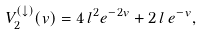<formula> <loc_0><loc_0><loc_500><loc_500>V ^ { ( \downarrow ) } _ { 2 } ( v ) = 4 \, l ^ { 2 } e ^ { - 2 v } + 2 \, l \, e ^ { - v } ,</formula> 